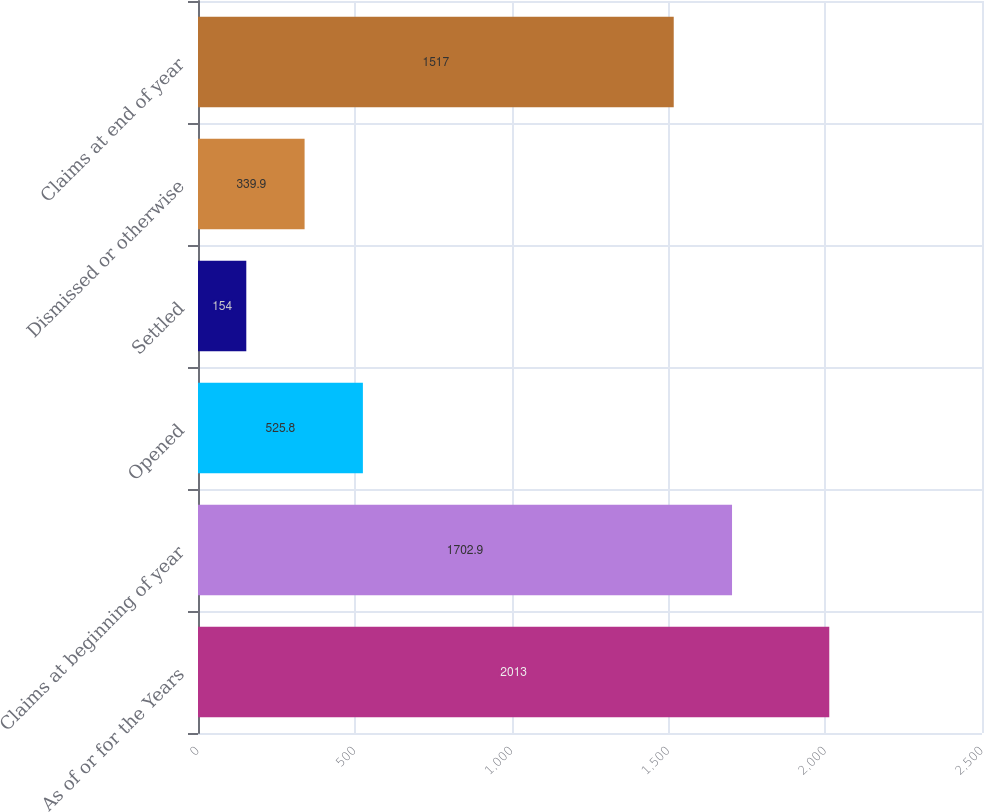<chart> <loc_0><loc_0><loc_500><loc_500><bar_chart><fcel>As of or for the Years<fcel>Claims at beginning of year<fcel>Opened<fcel>Settled<fcel>Dismissed or otherwise<fcel>Claims at end of year<nl><fcel>2013<fcel>1702.9<fcel>525.8<fcel>154<fcel>339.9<fcel>1517<nl></chart> 